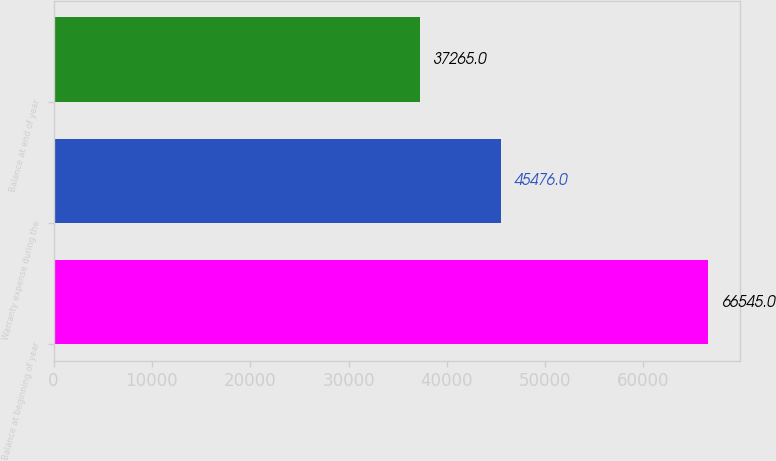Convert chart. <chart><loc_0><loc_0><loc_500><loc_500><bar_chart><fcel>Balance at beginning of year<fcel>Warranty expense during the<fcel>Balance at end of year<nl><fcel>66545<fcel>45476<fcel>37265<nl></chart> 